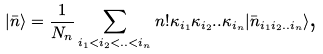Convert formula to latex. <formula><loc_0><loc_0><loc_500><loc_500>\left | \bar { n } \right \rangle = \frac { 1 } { N _ { n } } \sum _ { i _ { 1 } < i _ { 2 } < . . < i _ { n } } n ! \kappa _ { i _ { 1 } } \kappa _ { i _ { 2 } } . . \kappa _ { i _ { n } } | \bar { n } _ { i _ { 1 } i _ { 2 } . . i _ { n } } \rangle \text {,}</formula> 